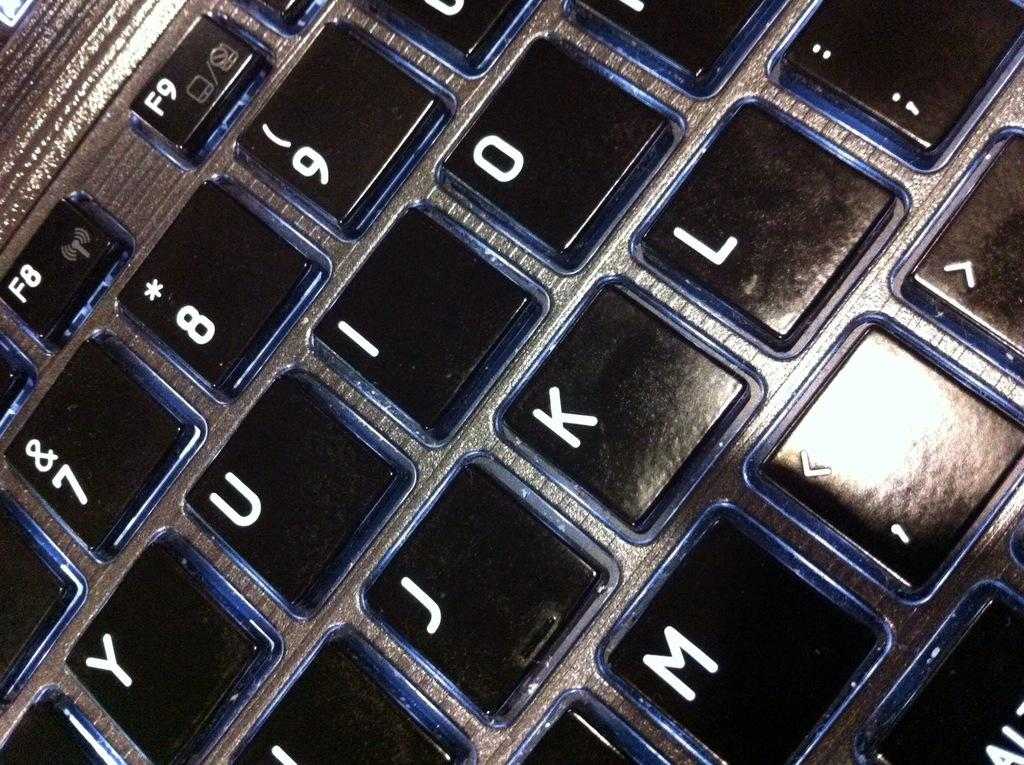<image>
Summarize the visual content of the image. a keyboard with many different letters on it 